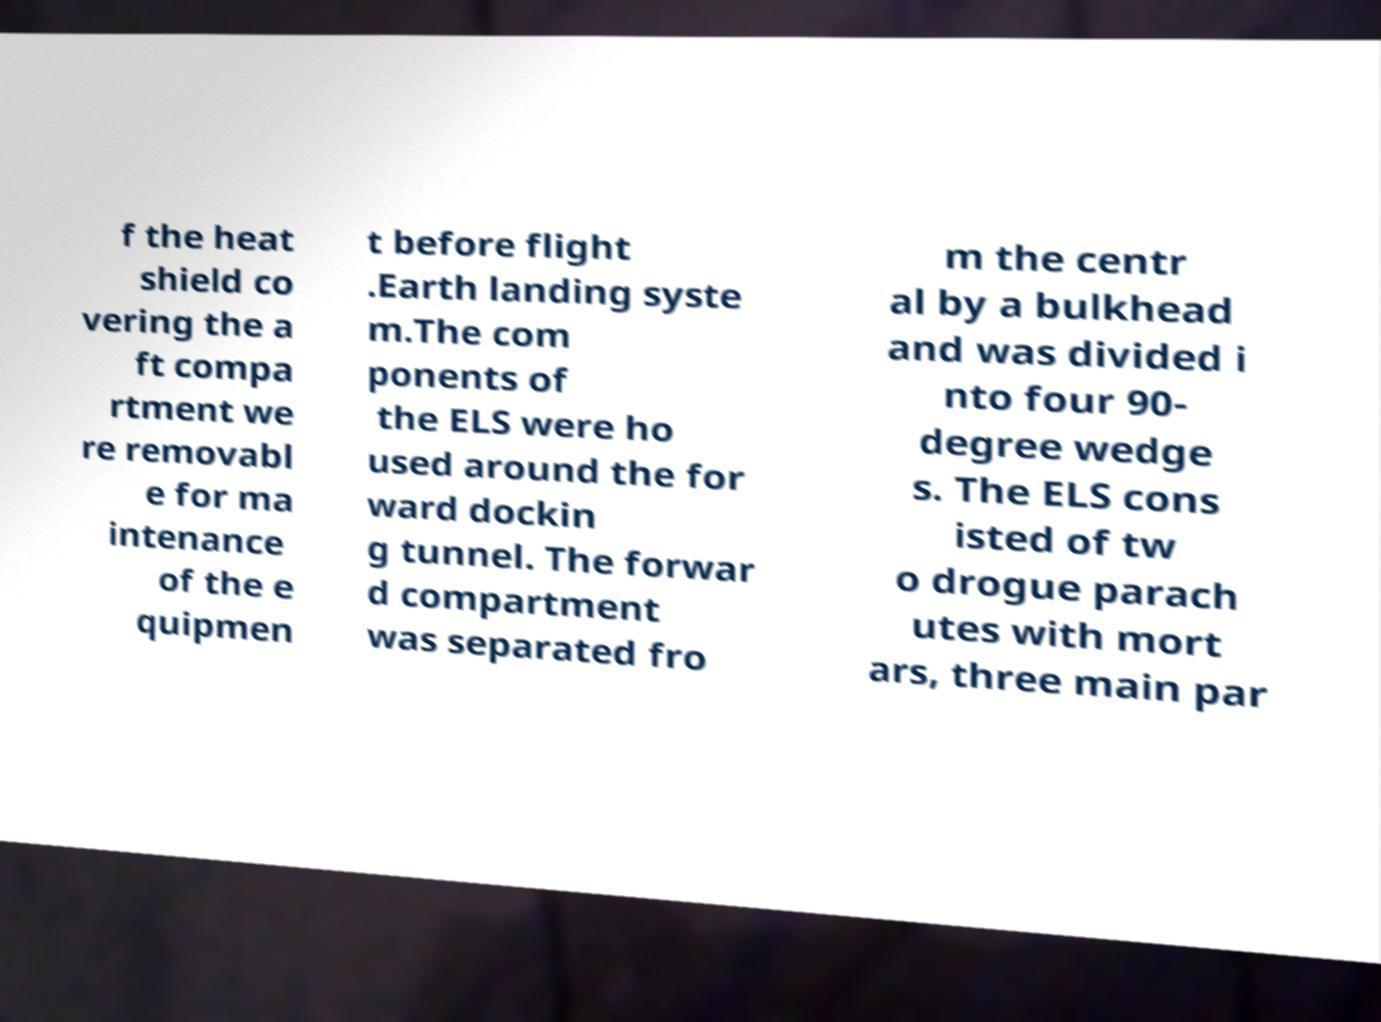Please read and relay the text visible in this image. What does it say? f the heat shield co vering the a ft compa rtment we re removabl e for ma intenance of the e quipmen t before flight .Earth landing syste m.The com ponents of the ELS were ho used around the for ward dockin g tunnel. The forwar d compartment was separated fro m the centr al by a bulkhead and was divided i nto four 90- degree wedge s. The ELS cons isted of tw o drogue parach utes with mort ars, three main par 